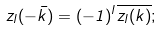<formula> <loc_0><loc_0><loc_500><loc_500>z _ { l } ( - \bar { k } ) = ( - 1 ) ^ { l } \overline { z _ { l } ( k ) } ;</formula> 